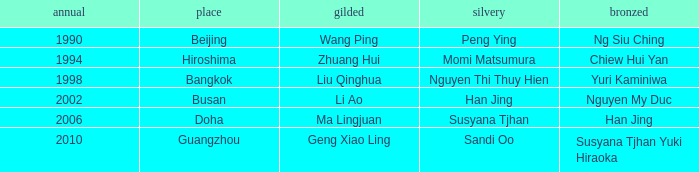What Silver has a Golf of Li AO? Han Jing. 